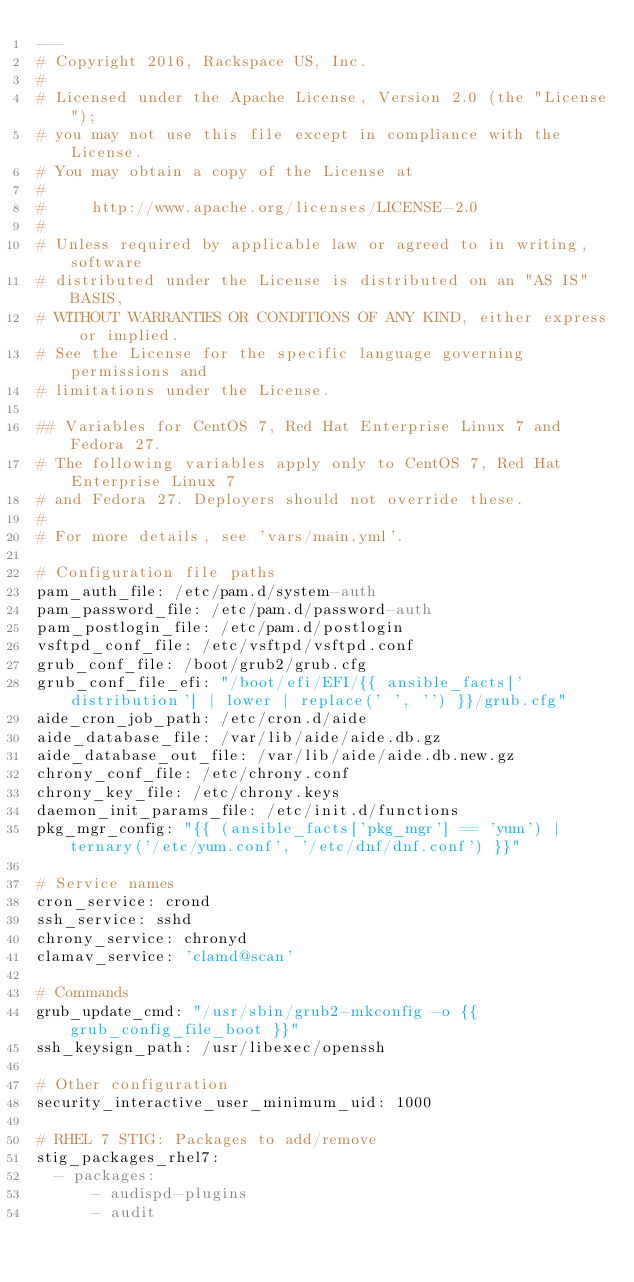<code> <loc_0><loc_0><loc_500><loc_500><_YAML_>---
# Copyright 2016, Rackspace US, Inc.
#
# Licensed under the Apache License, Version 2.0 (the "License");
# you may not use this file except in compliance with the License.
# You may obtain a copy of the License at
#
#     http://www.apache.org/licenses/LICENSE-2.0
#
# Unless required by applicable law or agreed to in writing, software
# distributed under the License is distributed on an "AS IS" BASIS,
# WITHOUT WARRANTIES OR CONDITIONS OF ANY KIND, either express or implied.
# See the License for the specific language governing permissions and
# limitations under the License.

## Variables for CentOS 7, Red Hat Enterprise Linux 7 and Fedora 27.
# The following variables apply only to CentOS 7, Red Hat Enterprise Linux 7
# and Fedora 27. Deployers should not override these.
#
# For more details, see 'vars/main.yml'.

# Configuration file paths
pam_auth_file: /etc/pam.d/system-auth
pam_password_file: /etc/pam.d/password-auth
pam_postlogin_file: /etc/pam.d/postlogin
vsftpd_conf_file: /etc/vsftpd/vsftpd.conf
grub_conf_file: /boot/grub2/grub.cfg
grub_conf_file_efi: "/boot/efi/EFI/{{ ansible_facts['distribution'] | lower | replace(' ', '') }}/grub.cfg"
aide_cron_job_path: /etc/cron.d/aide
aide_database_file: /var/lib/aide/aide.db.gz
aide_database_out_file: /var/lib/aide/aide.db.new.gz
chrony_conf_file: /etc/chrony.conf
chrony_key_file: /etc/chrony.keys
daemon_init_params_file: /etc/init.d/functions
pkg_mgr_config: "{{ (ansible_facts['pkg_mgr'] == 'yum') | ternary('/etc/yum.conf', '/etc/dnf/dnf.conf') }}"

# Service names
cron_service: crond
ssh_service: sshd
chrony_service: chronyd
clamav_service: 'clamd@scan'

# Commands
grub_update_cmd: "/usr/sbin/grub2-mkconfig -o {{ grub_config_file_boot }}"
ssh_keysign_path: /usr/libexec/openssh

# Other configuration
security_interactive_user_minimum_uid: 1000

# RHEL 7 STIG: Packages to add/remove
stig_packages_rhel7:
  - packages:
      - audispd-plugins
      - audit</code> 